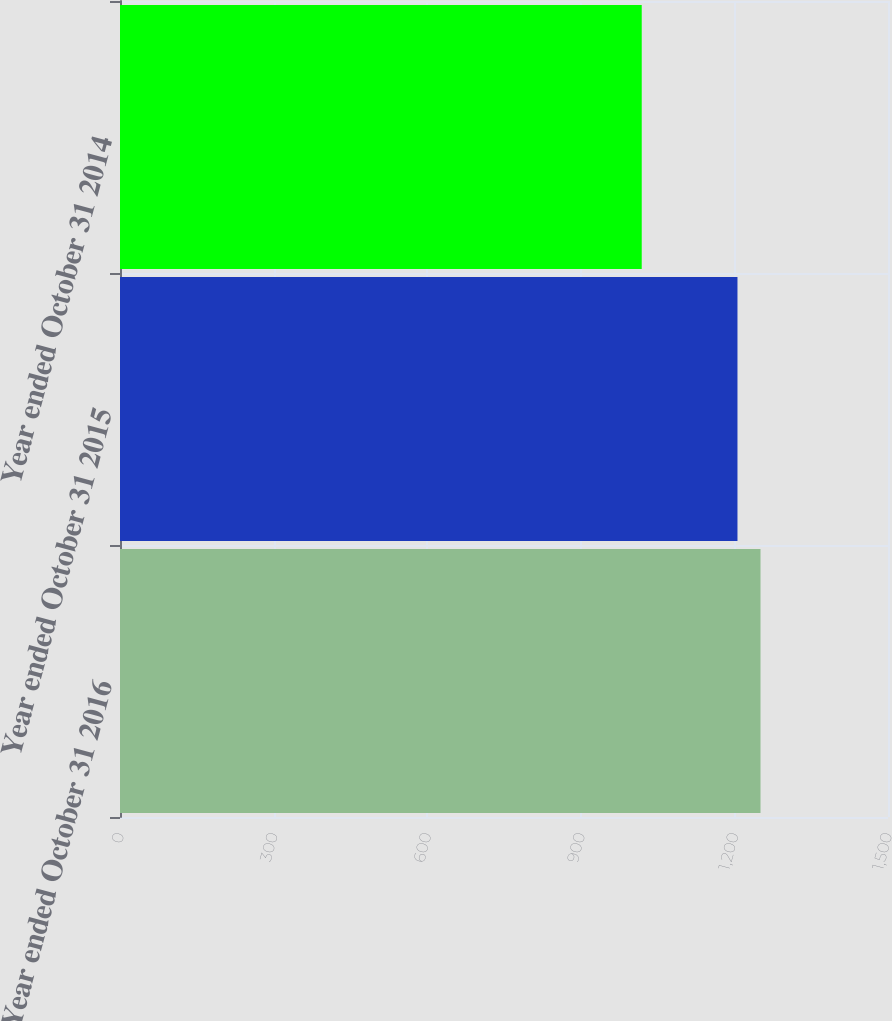<chart> <loc_0><loc_0><loc_500><loc_500><bar_chart><fcel>Year ended October 31 2016<fcel>Year ended October 31 2015<fcel>Year ended October 31 2014<nl><fcel>1251<fcel>1206<fcel>1019<nl></chart> 